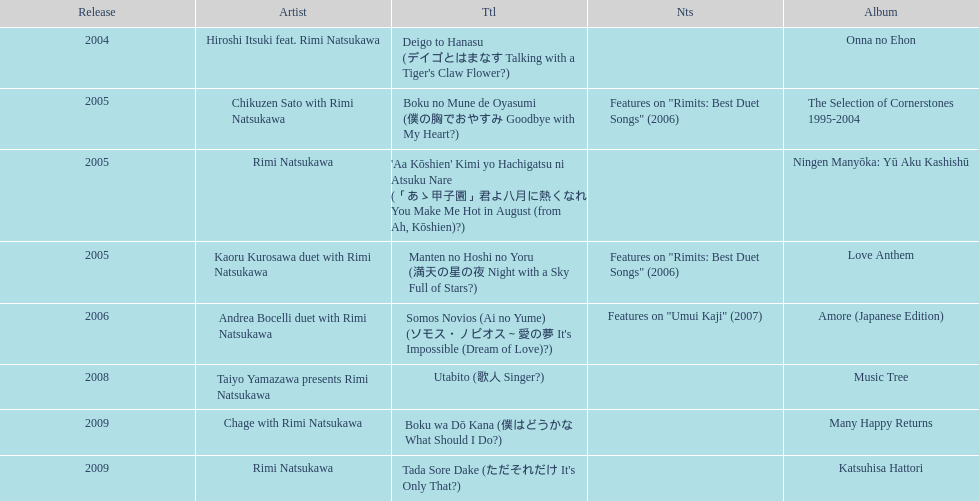I'm looking to parse the entire table for insights. Could you assist me with that? {'header': ['Release', 'Artist', 'Ttl', 'Nts', 'Album'], 'rows': [['2004', 'Hiroshi Itsuki feat. Rimi Natsukawa', "Deigo to Hanasu (デイゴとはまなす Talking with a Tiger's Claw Flower?)", '', 'Onna no Ehon'], ['2005', 'Chikuzen Sato with Rimi Natsukawa', 'Boku no Mune de Oyasumi (僕の胸でおやすみ Goodbye with My Heart?)', 'Features on "Rimits: Best Duet Songs" (2006)', 'The Selection of Cornerstones 1995-2004'], ['2005', 'Rimi Natsukawa', "'Aa Kōshien' Kimi yo Hachigatsu ni Atsuku Nare (「あゝ甲子園」君よ八月に熱くなれ You Make Me Hot in August (from Ah, Kōshien)?)", '', 'Ningen Manyōka: Yū Aku Kashishū'], ['2005', 'Kaoru Kurosawa duet with Rimi Natsukawa', 'Manten no Hoshi no Yoru (満天の星の夜 Night with a Sky Full of Stars?)', 'Features on "Rimits: Best Duet Songs" (2006)', 'Love Anthem'], ['2006', 'Andrea Bocelli duet with Rimi Natsukawa', "Somos Novios (Ai no Yume) (ソモス・ノビオス～愛の夢 It's Impossible (Dream of Love)?)", 'Features on "Umui Kaji" (2007)', 'Amore (Japanese Edition)'], ['2008', 'Taiyo Yamazawa presents Rimi Natsukawa', 'Utabito (歌人 Singer?)', '', 'Music Tree'], ['2009', 'Chage with Rimi Natsukawa', 'Boku wa Dō Kana (僕はどうかな What Should I Do?)', '', 'Many Happy Returns'], ['2009', 'Rimi Natsukawa', "Tada Sore Dake (ただそれだけ It's Only That?)", '', 'Katsuhisa Hattori']]} Which year had the most titles released? 2005. 